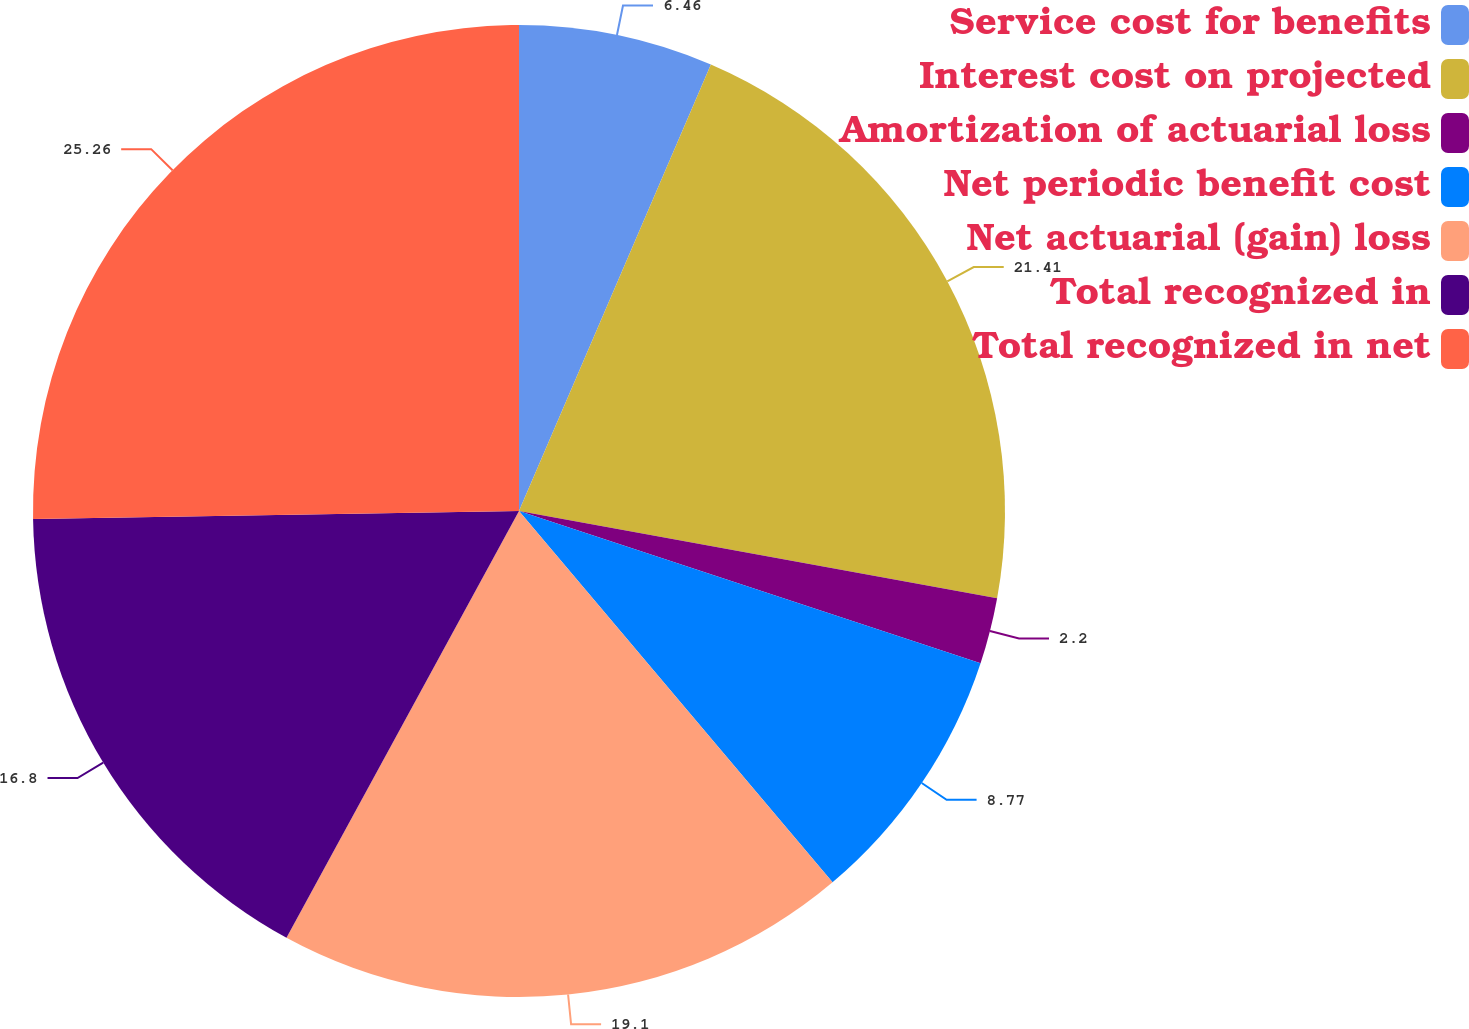Convert chart to OTSL. <chart><loc_0><loc_0><loc_500><loc_500><pie_chart><fcel>Service cost for benefits<fcel>Interest cost on projected<fcel>Amortization of actuarial loss<fcel>Net periodic benefit cost<fcel>Net actuarial (gain) loss<fcel>Total recognized in<fcel>Total recognized in net<nl><fcel>6.46%<fcel>21.41%<fcel>2.2%<fcel>8.77%<fcel>19.1%<fcel>16.8%<fcel>25.26%<nl></chart> 